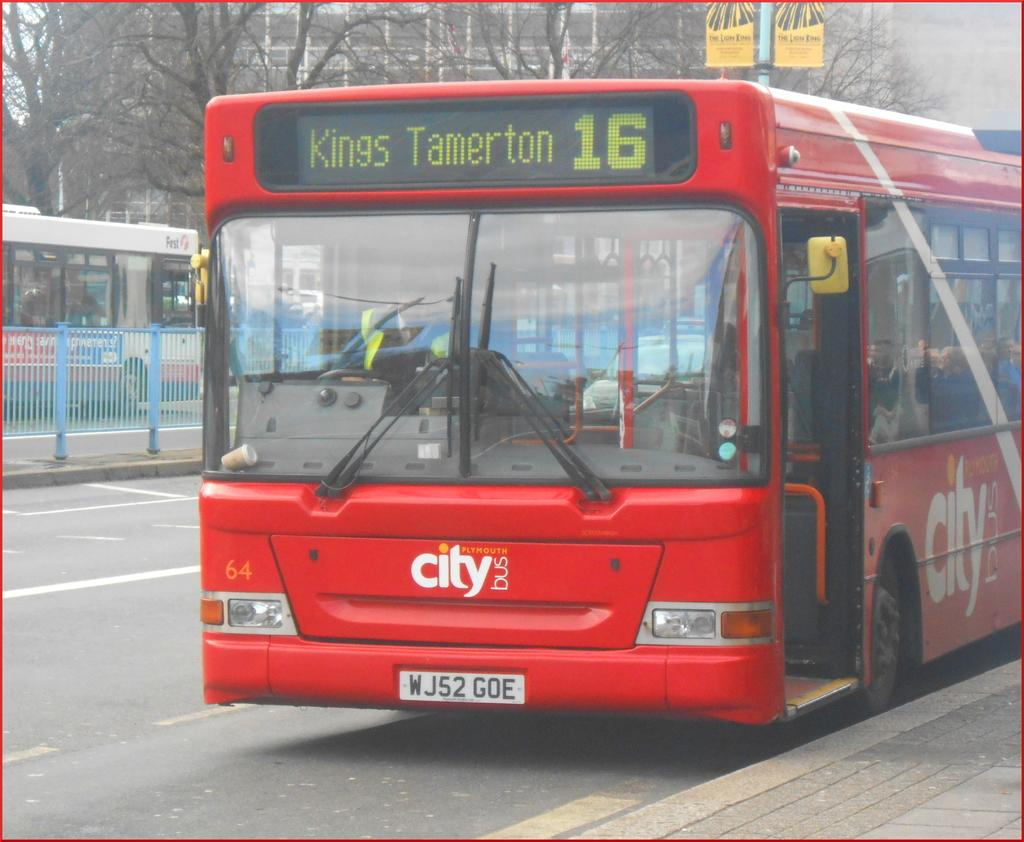<image>
Relay a brief, clear account of the picture shown. A red city bus bound for Kings Tamerton 16. 